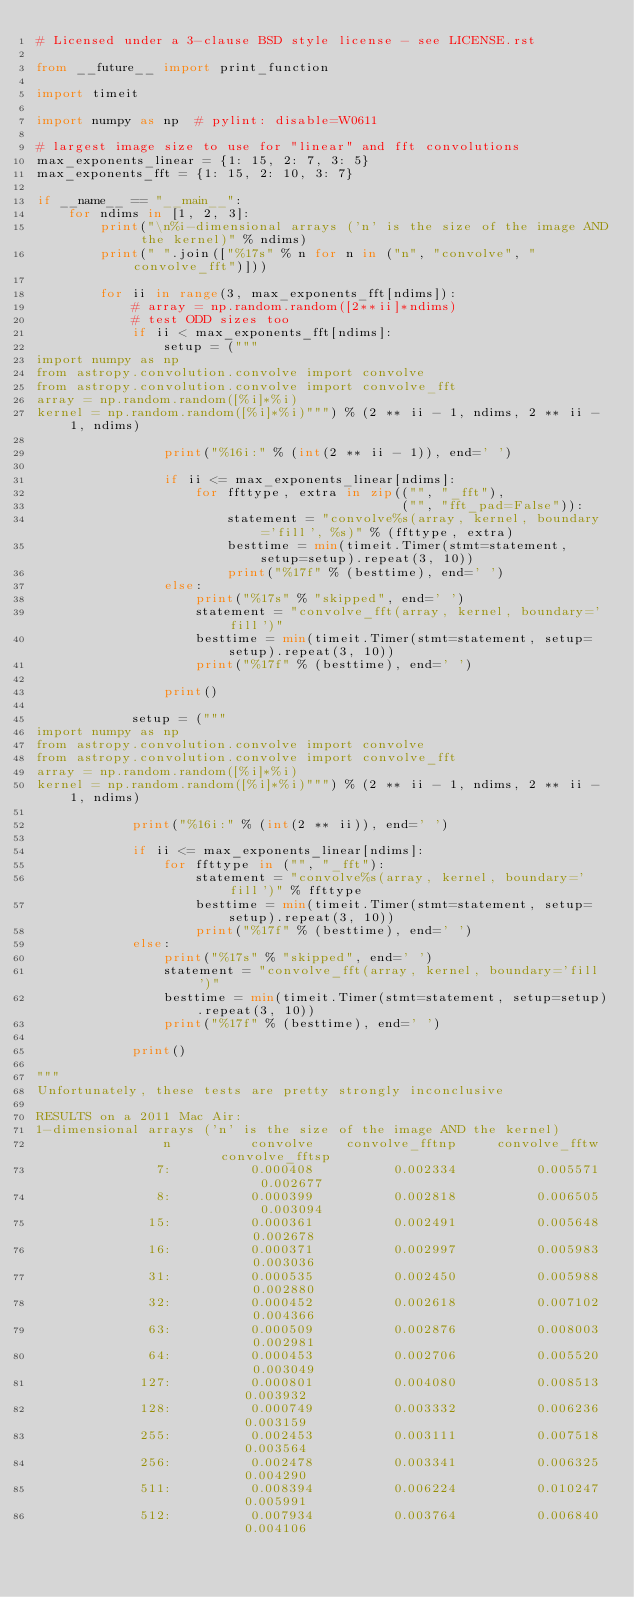<code> <loc_0><loc_0><loc_500><loc_500><_Python_># Licensed under a 3-clause BSD style license - see LICENSE.rst

from __future__ import print_function

import timeit

import numpy as np  # pylint: disable=W0611

# largest image size to use for "linear" and fft convolutions
max_exponents_linear = {1: 15, 2: 7, 3: 5}
max_exponents_fft = {1: 15, 2: 10, 3: 7}

if __name__ == "__main__":
    for ndims in [1, 2, 3]:
        print("\n%i-dimensional arrays ('n' is the size of the image AND the kernel)" % ndims)
        print(" ".join(["%17s" % n for n in ("n", "convolve", "convolve_fft")]))

        for ii in range(3, max_exponents_fft[ndims]):
            # array = np.random.random([2**ii]*ndims)
            # test ODD sizes too
            if ii < max_exponents_fft[ndims]:
                setup = ("""
import numpy as np
from astropy.convolution.convolve import convolve
from astropy.convolution.convolve import convolve_fft
array = np.random.random([%i]*%i)
kernel = np.random.random([%i]*%i)""") % (2 ** ii - 1, ndims, 2 ** ii - 1, ndims)

                print("%16i:" % (int(2 ** ii - 1)), end=' ')

                if ii <= max_exponents_linear[ndims]:
                    for ffttype, extra in zip(("", "_fft"),
                                              ("", "fft_pad=False")):
                        statement = "convolve%s(array, kernel, boundary='fill', %s)" % (ffttype, extra)
                        besttime = min(timeit.Timer(stmt=statement, setup=setup).repeat(3, 10))
                        print("%17f" % (besttime), end=' ')
                else:
                    print("%17s" % "skipped", end=' ')
                    statement = "convolve_fft(array, kernel, boundary='fill')"
                    besttime = min(timeit.Timer(stmt=statement, setup=setup).repeat(3, 10))
                    print("%17f" % (besttime), end=' ')

                print()

            setup = ("""
import numpy as np
from astropy.convolution.convolve import convolve
from astropy.convolution.convolve import convolve_fft
array = np.random.random([%i]*%i)
kernel = np.random.random([%i]*%i)""") % (2 ** ii - 1, ndims, 2 ** ii - 1, ndims)

            print("%16i:" % (int(2 ** ii)), end=' ')

            if ii <= max_exponents_linear[ndims]:
                for ffttype in ("", "_fft"):
                    statement = "convolve%s(array, kernel, boundary='fill')" % ffttype
                    besttime = min(timeit.Timer(stmt=statement, setup=setup).repeat(3, 10))
                    print("%17f" % (besttime), end=' ')
            else:
                print("%17s" % "skipped", end=' ')
                statement = "convolve_fft(array, kernel, boundary='fill')"
                besttime = min(timeit.Timer(stmt=statement, setup=setup).repeat(3, 10))
                print("%17f" % (besttime), end=' ')

            print()

"""
Unfortunately, these tests are pretty strongly inconclusive

RESULTS on a 2011 Mac Air:
1-dimensional arrays ('n' is the size of the image AND the kernel)
                n          convolve    convolve_fftnp     convolve_fftw    convolve_fftsp
               7:          0.000408          0.002334          0.005571          0.002677
               8:          0.000399          0.002818          0.006505          0.003094
              15:          0.000361          0.002491          0.005648          0.002678
              16:          0.000371          0.002997          0.005983          0.003036
              31:          0.000535          0.002450          0.005988          0.002880
              32:          0.000452          0.002618          0.007102          0.004366
              63:          0.000509          0.002876          0.008003          0.002981
              64:          0.000453          0.002706          0.005520          0.003049
             127:          0.000801          0.004080          0.008513          0.003932
             128:          0.000749          0.003332          0.006236          0.003159
             255:          0.002453          0.003111          0.007518          0.003564
             256:          0.002478          0.003341          0.006325          0.004290
             511:          0.008394          0.006224          0.010247          0.005991
             512:          0.007934          0.003764          0.006840          0.004106</code> 